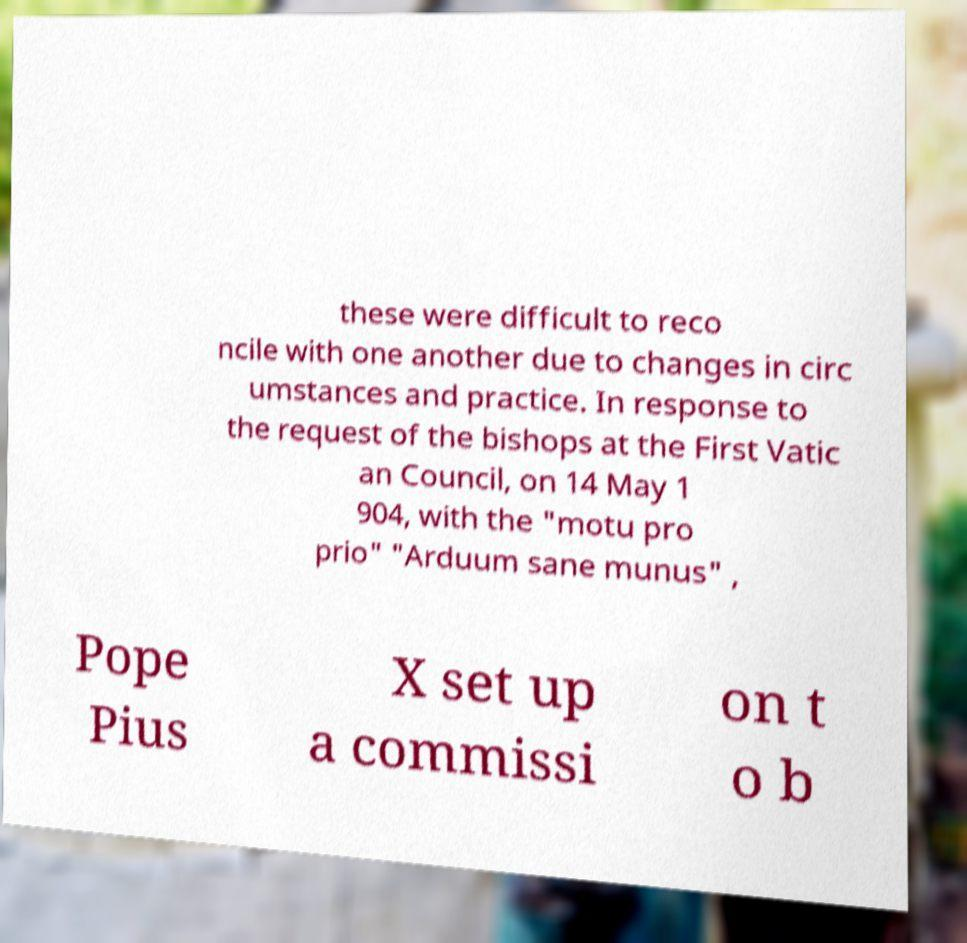For documentation purposes, I need the text within this image transcribed. Could you provide that? these were difficult to reco ncile with one another due to changes in circ umstances and practice. In response to the request of the bishops at the First Vatic an Council, on 14 May 1 904, with the "motu pro prio" "Arduum sane munus" , Pope Pius X set up a commissi on t o b 